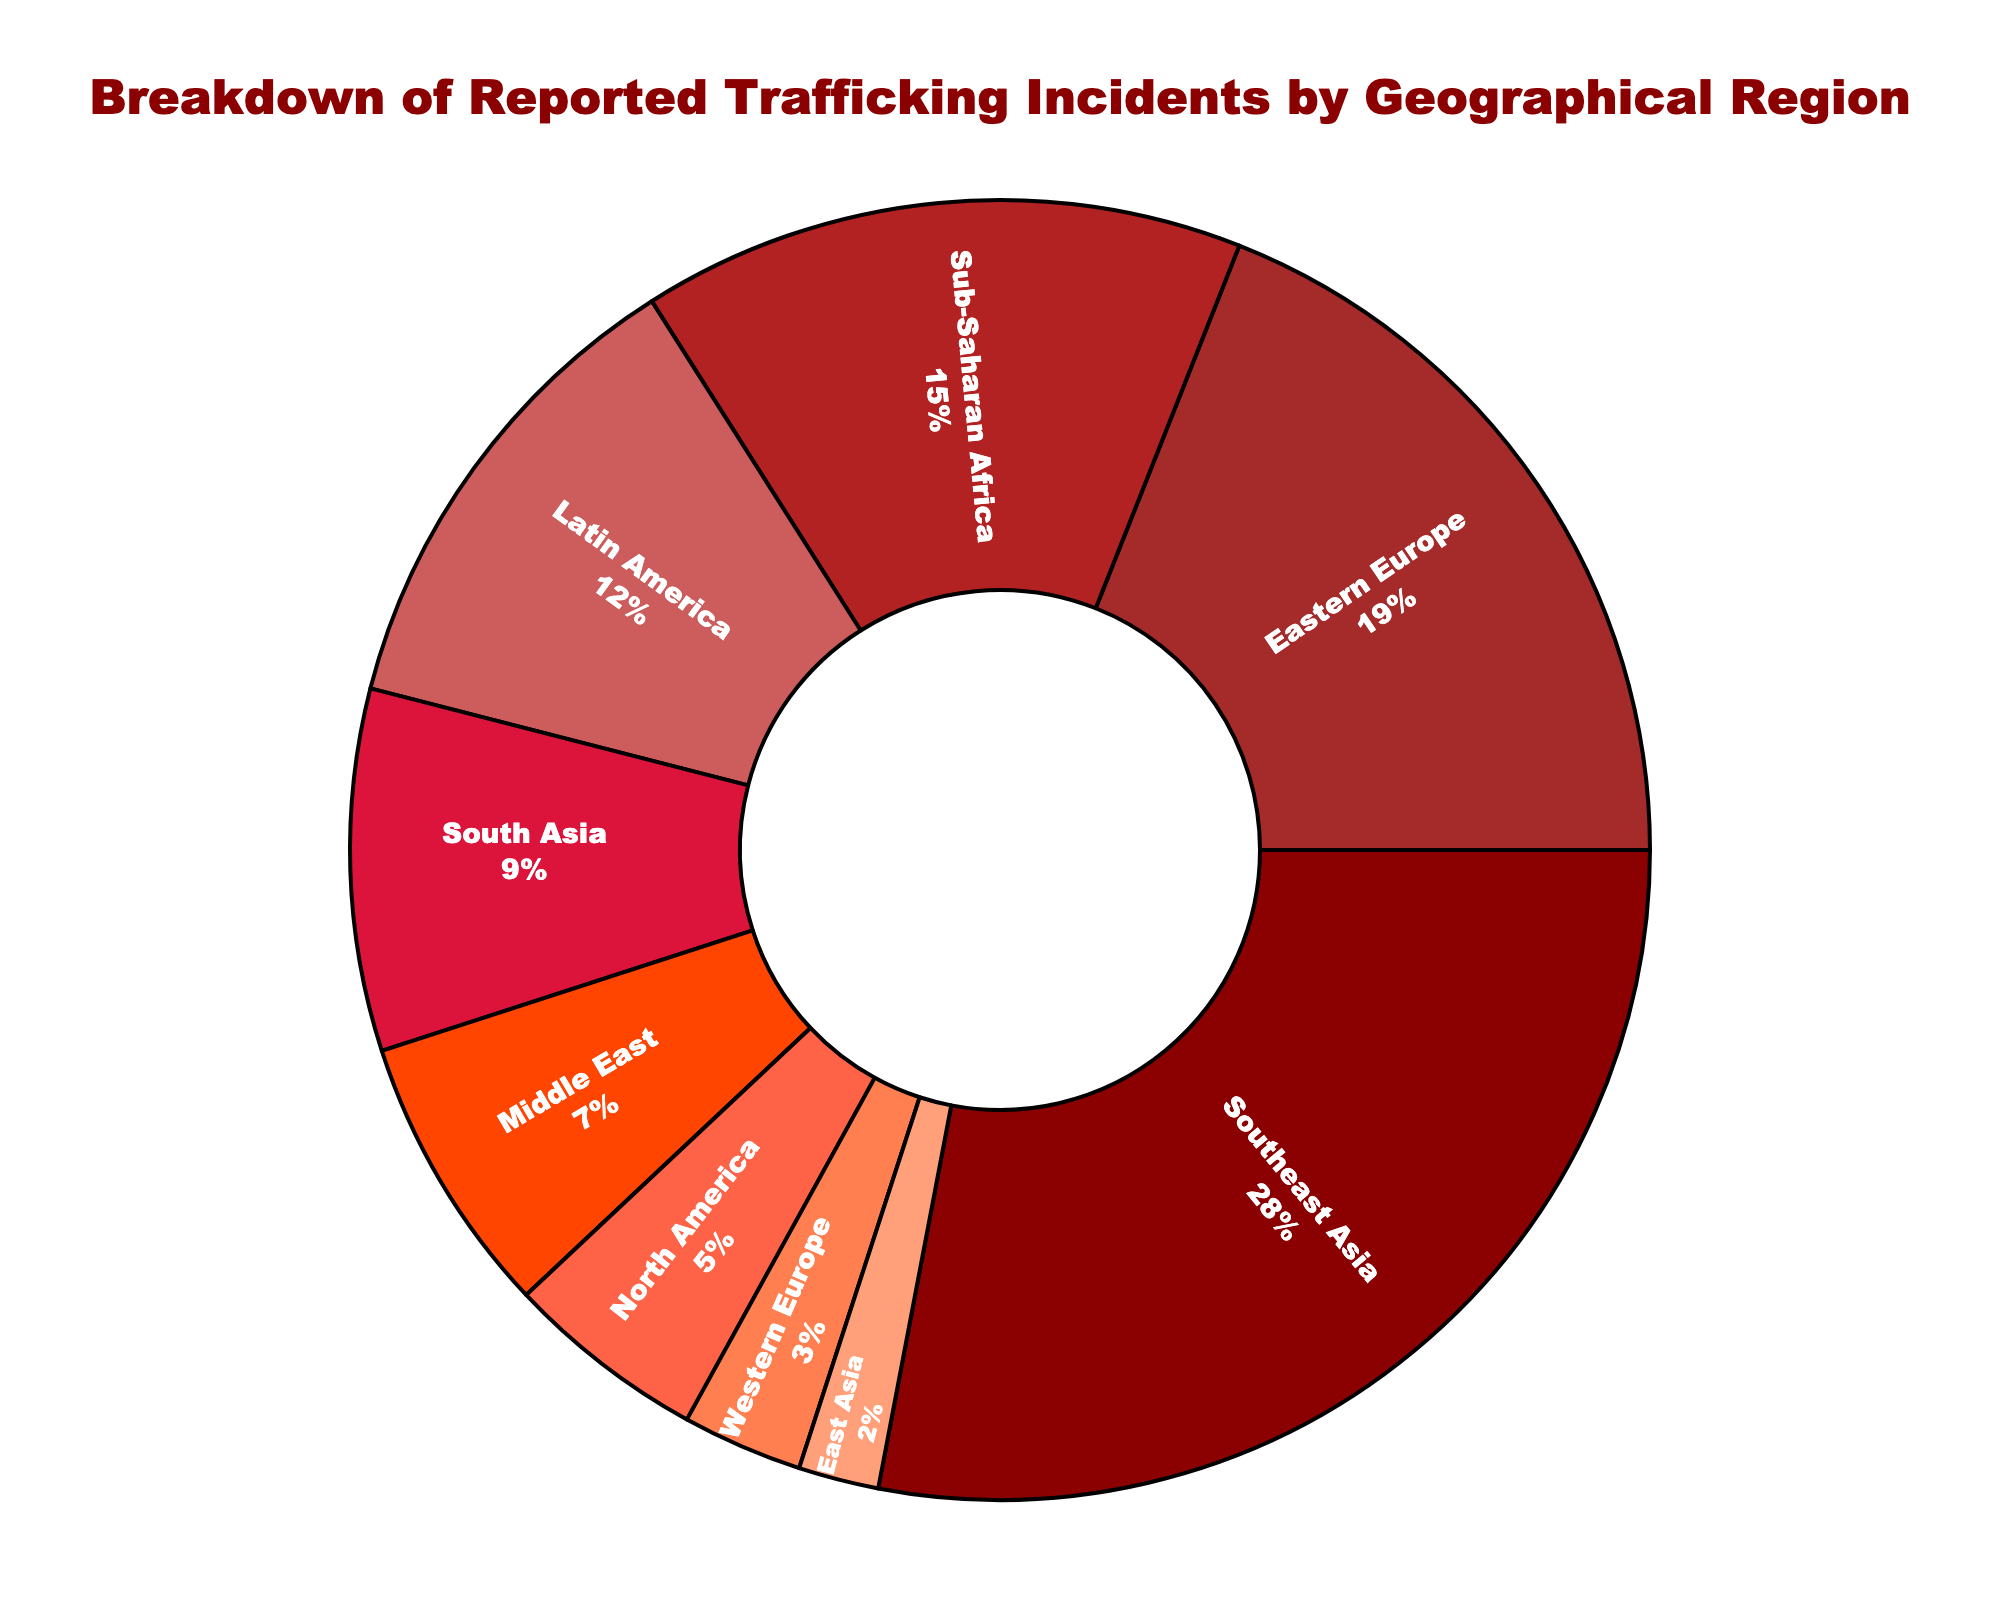what percentage of reported trafficking incidents is from Southeast Asia? Look at the slice labeled "Southeast Asia" on the pie chart. The percentage value displayed inside the slice is 28%.
Answer: 28% Which region has the highest percentage of reported trafficking incidents? Observe the pie chart and identify the largest slice. The largest slice is labeled "Southeast Asia" with 28%.
Answer: Southeast Asia Which region has the lowest percentage of reported trafficking incidents? Observe the pie chart and identify the smallest slice. The smallest slice is labeled "East Asia" with 2%.
Answer: East Asia What is the combined percentage of reported trafficking incidents from Latin America and South Asia? Locate the slices labeled "Latin America" and "South Asia" on the pie chart. The percentages are 12% and 9%, respectively. Adding them together: 12% + 9% = 21%.
Answer: 21% How does the proportion of reported trafficking incidents in North America compare to that in Western Europe? Compare the size of the slices labeled "North America" (5%) and "Western Europe" (3%) on the pie chart. North America's slice is larger. Thus, 5% > 3%.
Answer: North America has a higher percentage Are the incidents reported in the Middle East more or less than those in Sub-Saharan Africa? Compare the slice labeled "Middle East" (7%) with the slice labeled "Sub-Saharan Africa" (15%) on the pie chart. The Middle East has a smaller percentage.
Answer: Less What is the difference in the percentage of reported trafficking incidents between Eastern Europe and Sub-Saharan Africa? Identify the slices for "Eastern Europe" (19%) and "Sub-Saharan Africa" (15%). Subtract the smaller percentage from the larger one: 19% - 15% = 4%.
Answer: 4% Determine the sum of percentages for the regions with percentages below 10%. Identify the regions "South Asia" (9%), "Middle East" (7%), "North America" (5%), "Western Europe" (3%), and "East Asia" (2%). Add them together: 9% + 7% + 5% + 3% + 2% = 26%.
Answer: 26% Which slice appears with the darkest shade of red and what percentage does it represent? Observe the pie chart and identify the slice with the darkest red shade. The slice labeled "Southeast Asia" has the darkest shade and represents 28%.
Answer: Southeast Asia with 28% How does the combined percentage of North America and Eastern Europe compare to Southeast Asia? Add the percentages of North America (5%) and Eastern Europe (19%): 5% + 19% = 24%. Compare 24% with Southeast Asia's 28%. Since 24% < 28%, Southeast Asia has a higher percentage.
Answer: Southeast Asia has a higher percentage 